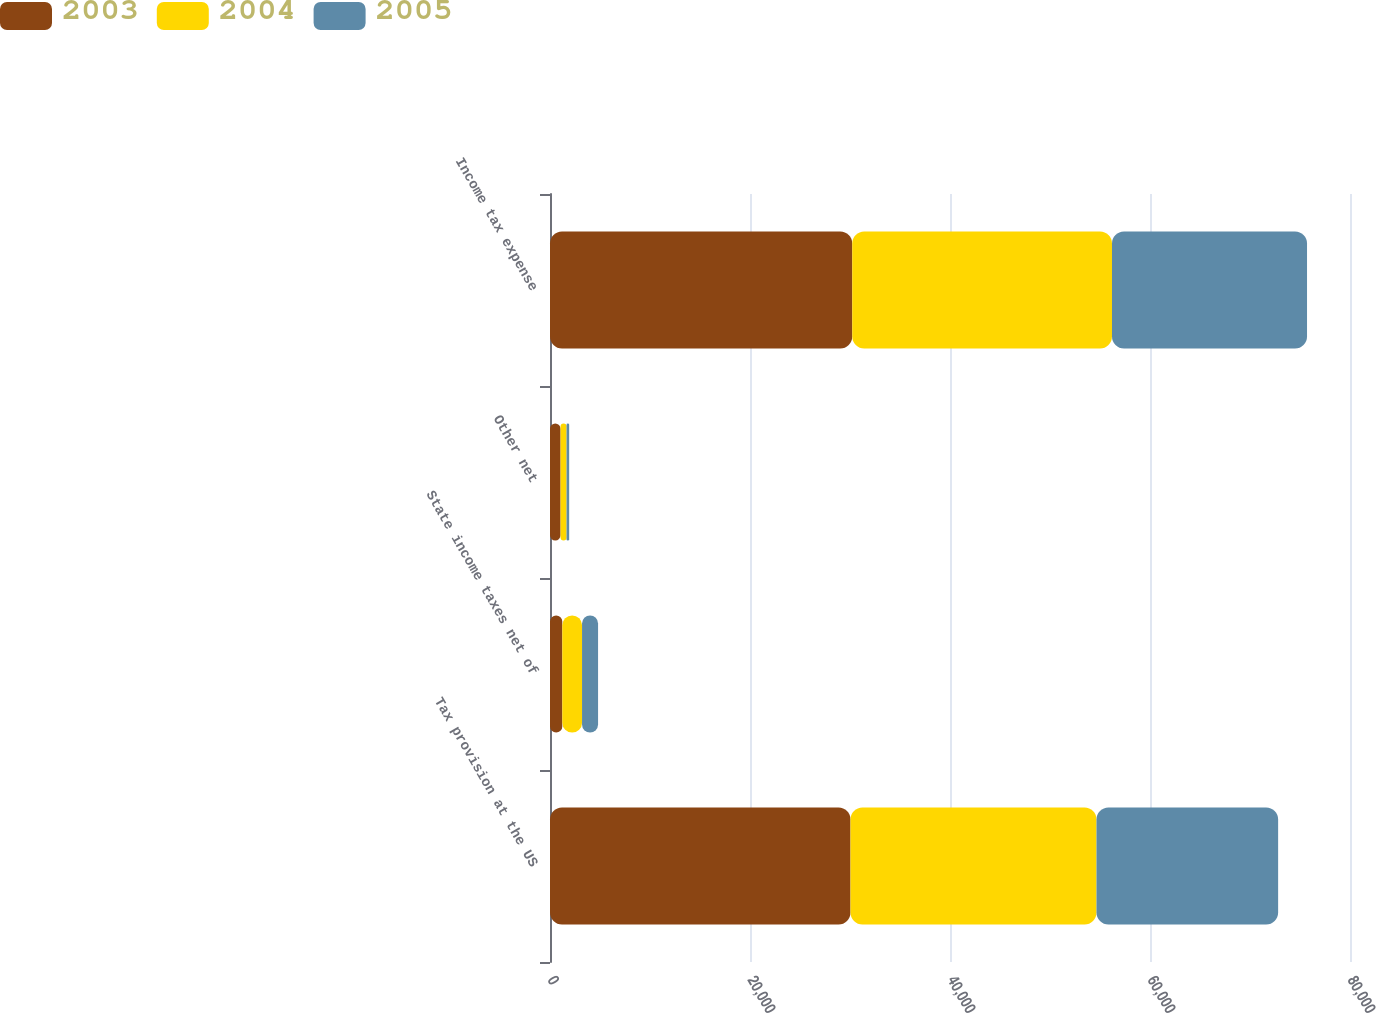Convert chart. <chart><loc_0><loc_0><loc_500><loc_500><stacked_bar_chart><ecel><fcel>Tax provision at the US<fcel>State income taxes net of<fcel>Other net<fcel>Income tax expense<nl><fcel>2003<fcel>30050<fcel>1230<fcel>1056<fcel>30224<nl><fcel>2004<fcel>24600<fcel>1975<fcel>600<fcel>25975<nl><fcel>2005<fcel>18163<fcel>1602<fcel>261<fcel>19504<nl></chart> 